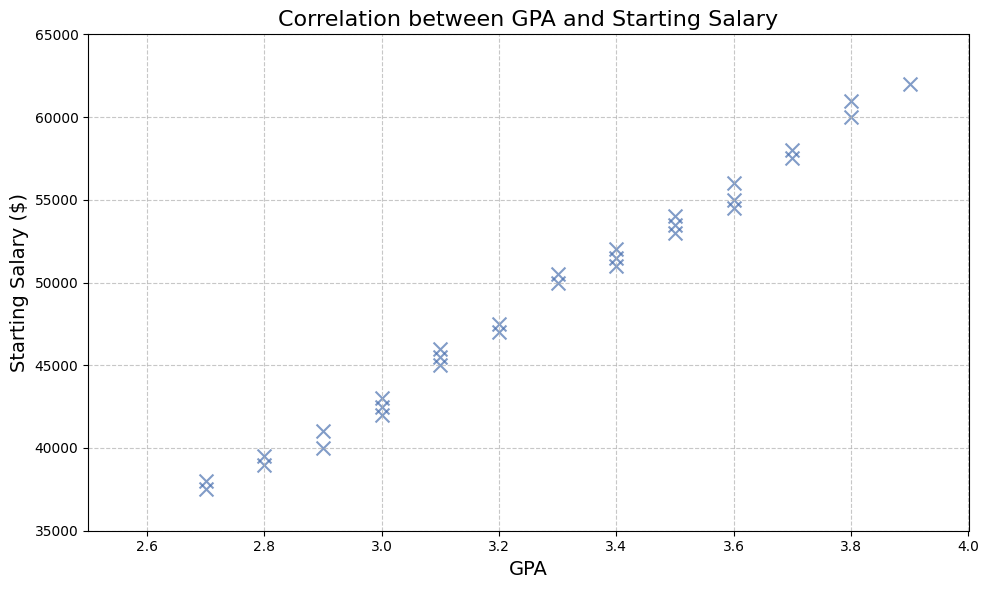Which student has the highest starting salary? The highest starting salary is $62,000. The corresponding data point for a GPA is 3.9 and the matching StudentID is 26.
Answer: StudentID 26 What is the overall trend between GPA and starting salary? By observing the scatter plot, the general trend shows that as the GPA increases, the starting salary tends to increase as well. This suggests a positive correlation between GPA and starting salary.
Answer: Positive correlation What is the starting salary for a student with a GPA of 2.7? The scatter plot has data points at GPA = 2.7. By referencing these points, the starting salaries are around $37,500 and $38,000.
Answer: $37,500 and $38,000 What is the average starting salary for students with a GPA of 3.0? From the scatter plot, the data points for GPA = 3.0 have starting salaries of $42,000, $43,000, and $42,500. Sum these values (42,000 + 43,000 + 42,500) and divide by the number of students (3).
Answer: $42,500 Is there any student with a GPA below 3.4 but a starting salary above $50,000? To find such a student, look at the scatter plot for data points with GPA < 3.4 and Starting Salary > $50,000. There are no such data points in this scatter plot.
Answer: No Which GPA range has the most students earning above $55,000? By inspecting data points where starting salaries are above $55,000, it is seen that GPAs of 3.6, 3.7, 3.8, and 3.9 have the most data points fitting this criteria.
Answer: 3.6 to 3.9 How many students have a GPA of 3.8? Check the scatter plot for data points where GPA = 3.8, there are two points corresponding to starting salaries $60,000 and $61,000.
Answer: 2 What is the difference in starting salary between the highest and lowest GPA data points? Identify the highest GPA (3.9) with a starting salary of $62,000 and the lowest GPA (2.7) with starting salaries of $37,500-$38,000. Using the average of the lowest range (37,750) for clarity, the difference is ($62,000 - $37,750).
Answer: $24,250 Which GPA has the widest range of starting salaries? By observing the spread of data points vertically along the GPA axis, GPA 3.1 stands out with starting salaries ranging approximately from $45,000 to $46,000.
Answer: GPA 3.1 